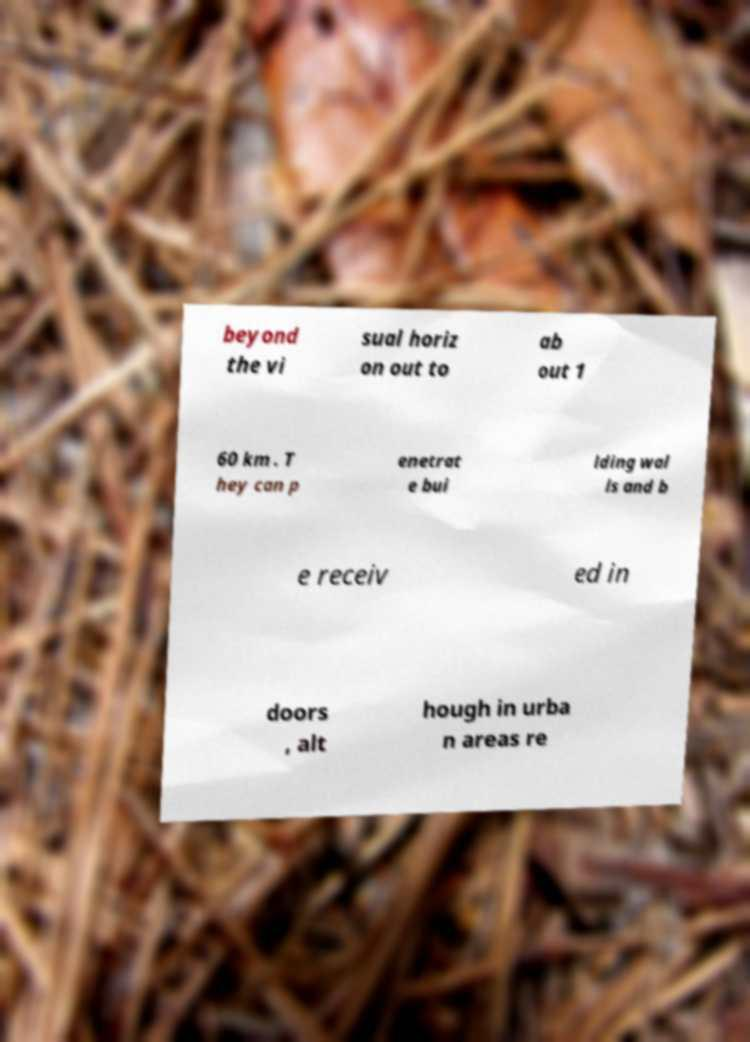I need the written content from this picture converted into text. Can you do that? beyond the vi sual horiz on out to ab out 1 60 km . T hey can p enetrat e bui lding wal ls and b e receiv ed in doors , alt hough in urba n areas re 